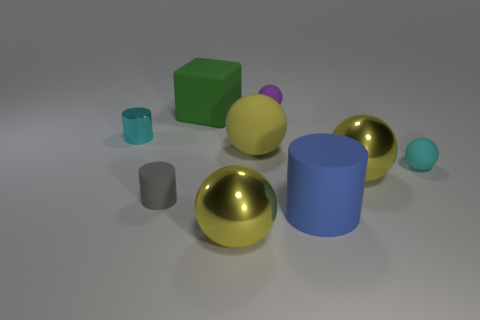There is a small shiny cylinder; does it have the same color as the small rubber sphere that is in front of the large green cube? yes 